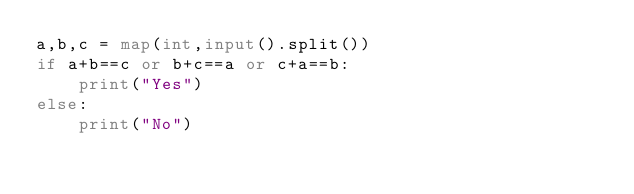<code> <loc_0><loc_0><loc_500><loc_500><_Python_>a,b,c = map(int,input().split())
if a+b==c or b+c==a or c+a==b:
    print("Yes")
else:
    print("No")
</code> 